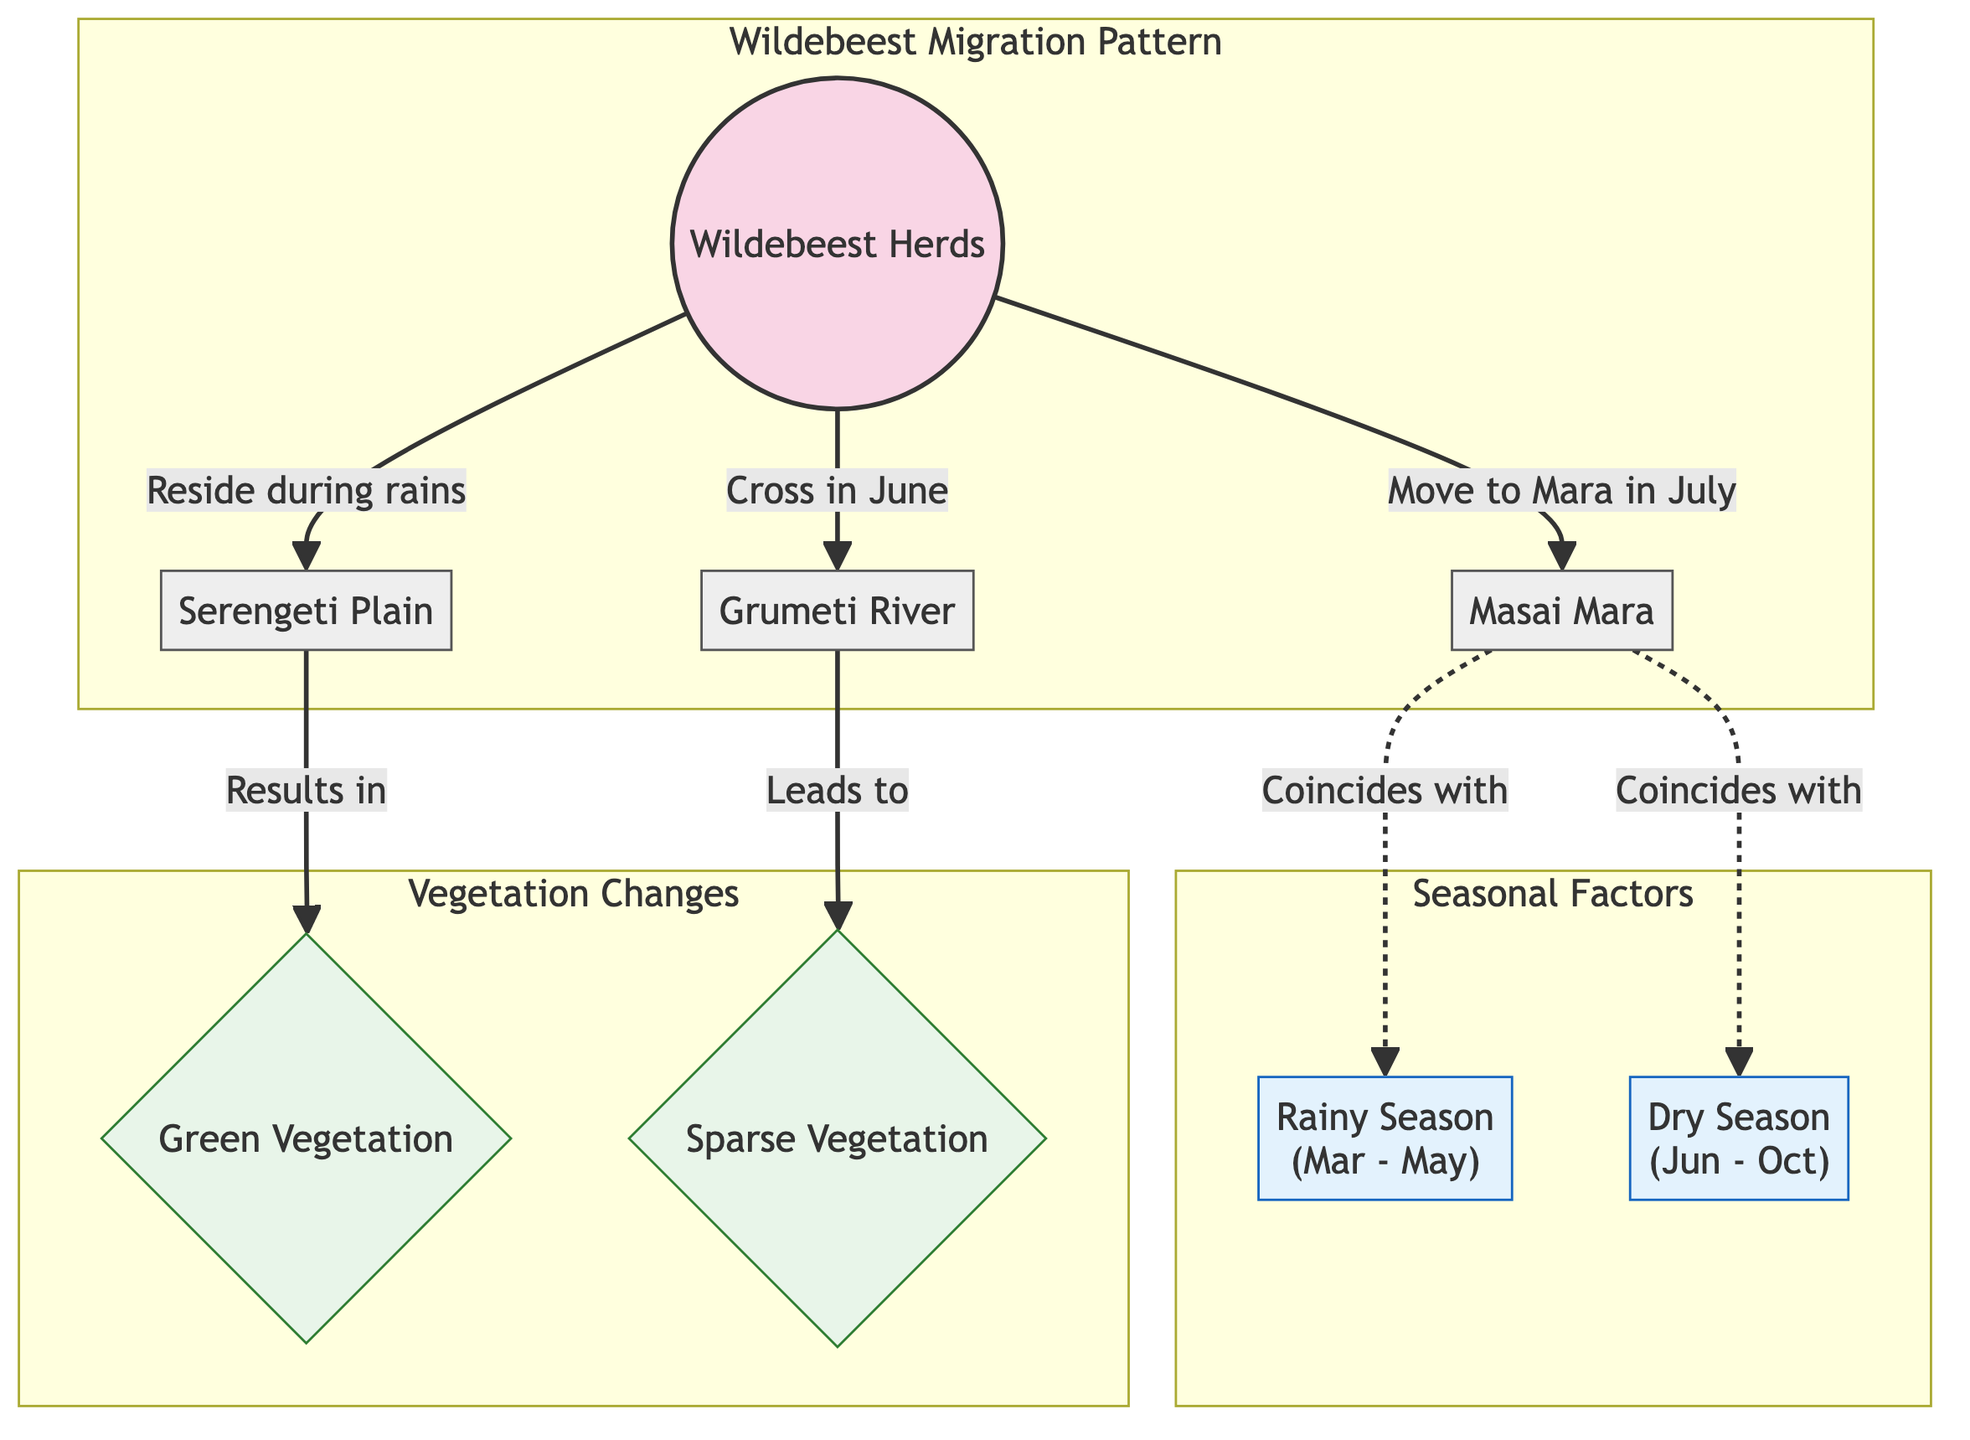What is the primary location where the wildebeest herds reside during the rainy season? The diagram indicates that the wildebeest herds reside in the Serengeti Plain during the rainy season as marked by the connection from the "Wildebeest Herds" node to the "Serengeti Plain" node with the label "Reside during rains."
Answer: Serengeti Plain What two key seasons are mentioned in the diagram? The diagram explicitly mentions two seasons: the Rainy Season from March to May and the Dry Season from June to October, as represented in the nodes labeled "Rainy Season" and "Dry Season."
Answer: Rainy Season, Dry Season How do the wildebeest herds interact with vegetation in the Serengeti? The diagram shows that during their residence in the Serengeti Plain, the wildebeest herds contribute to green vegetation growth, while their movement to the Grumeti River leads to sparse vegetation. The edges from "Serengeti Plain" to "Green Vegetation" and from "Grumeti River" to "Sparse Vegetation" illustrate these interactions.
Answer: Green Vegetation, Sparse Vegetation During which month do wildebeest herds cross the Grumeti River? The diagram specifically indicates that the wildebeest herds cross the Grumeti River in June, as denoted by the edge labeled "Cross in June."
Answer: June In what order do the wildebeest herds migrate from one location to another? According to the diagram, the order of migration for the wildebeest herds is first to reside in the Serengeti Plain during the rains, then cross to the Grumeti River in June, followed by moving to the Masai Mara in July. This sequence is reflected through the directed connections from one node to the next.
Answer: Serengeti Plain → Grumeti River → Masai Mara What is indicated about the relationship between the Masai Mara and the seasons? The diagram illustrates that the Masai Mara migration coincides with both the Rainy Season and the Dry Season, as indicated by the dashed lines connecting the Masai Mara node to both season nodes with the label "Coincides with."
Answer: Coincides with both seasons How many nodes related to vegetation changes are present in the diagram? The diagram contains two nodes that relate specifically to vegetation changes: "Green Vegetation" and "Sparse Vegetation," as represented in the Vegetation subgraph. Therefore, there are two nodes.
Answer: 2 What season does the movement to Masai Mara coincide with? The diagram shows that the movement to the Masai Mara coincides with both the Rainy Season and the Dry Season, which are represented by dashed connections to both season nodes.
Answer: Both seasons 